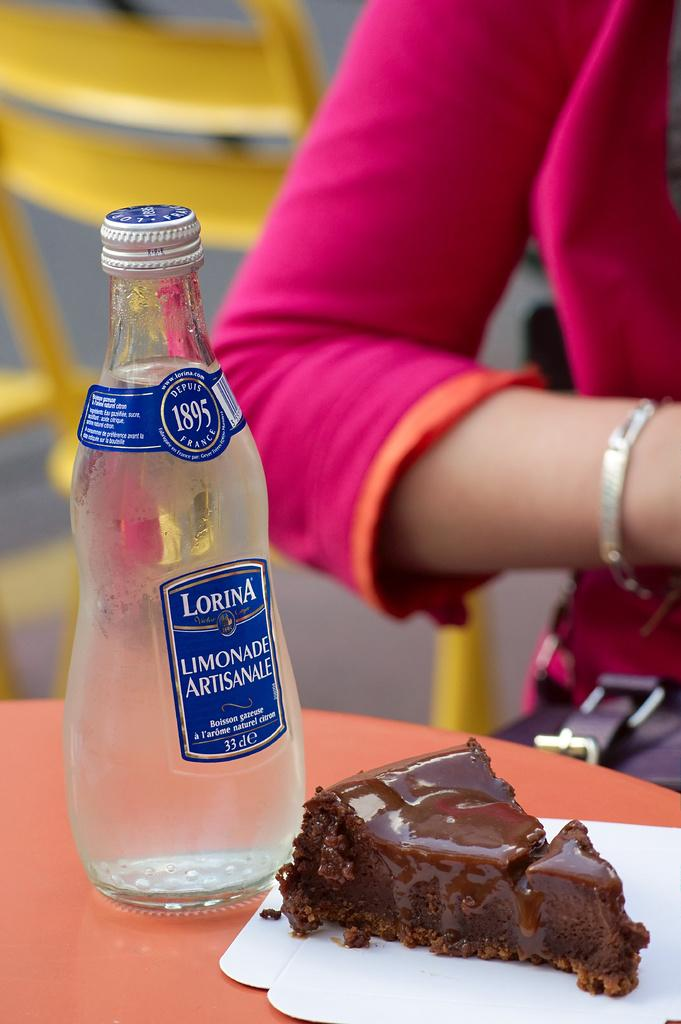What is one food item that can be seen in the image? There is a piece of cake in the image. What else can be seen in the image besides the cake? There is a bottle in the image. Can you describe any human presence in the image? A hand of a person is visible in the image. How many pies are being held by the person in the image? There are no pies visible in the image. What type of potato is being used to decorate the cake in the image? There are no potatoes present in the image, and the cake is not being decorated with any potato. 